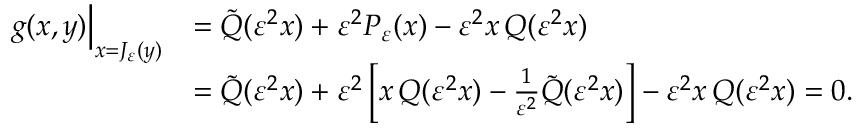Convert formula to latex. <formula><loc_0><loc_0><loc_500><loc_500>\begin{array} { r l } { g ( x , y ) \Big | _ { x = J _ { \varepsilon } ( y ) } } & { = \tilde { Q } ( \varepsilon ^ { 2 } x ) + \varepsilon ^ { 2 } P _ { \varepsilon } ( x ) - \varepsilon ^ { 2 } x \, Q ( \varepsilon ^ { 2 } x ) } \\ & { = \tilde { Q } ( \varepsilon ^ { 2 } x ) + \varepsilon ^ { 2 } \left [ x \, Q ( \varepsilon ^ { 2 } x ) - \frac { 1 } { \varepsilon ^ { 2 } } \tilde { Q } ( \varepsilon ^ { 2 } x ) \right ] - \varepsilon ^ { 2 } x \, Q ( \varepsilon ^ { 2 } x ) = 0 . } \end{array}</formula> 